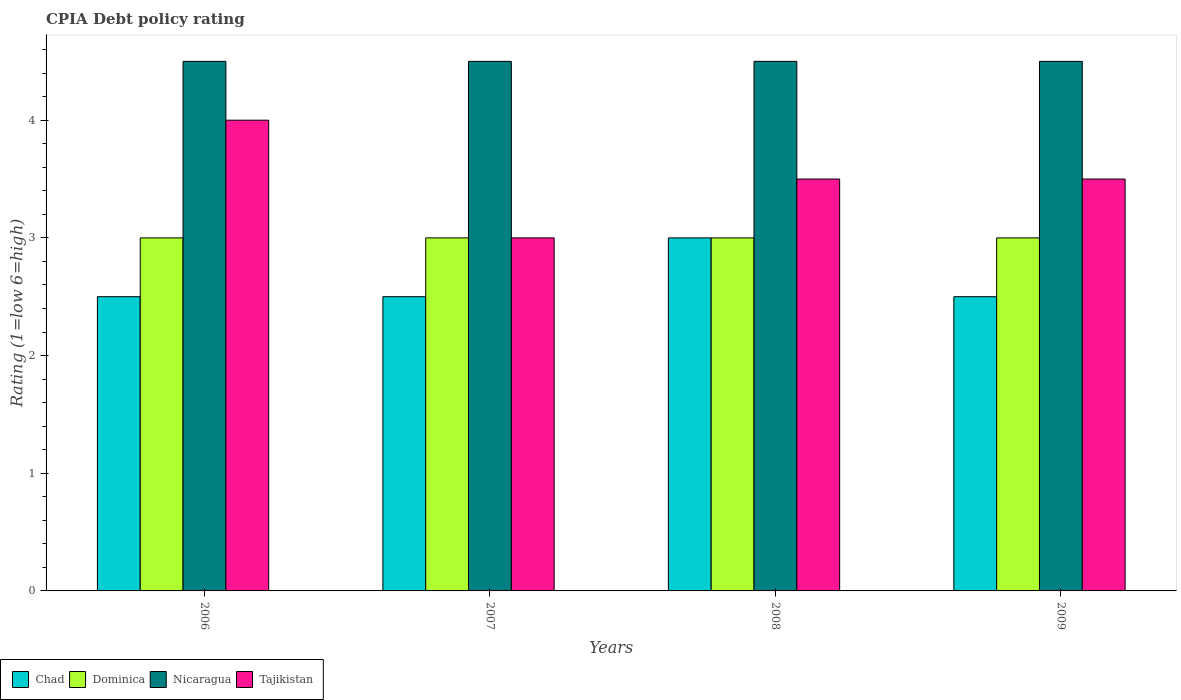How many different coloured bars are there?
Provide a short and direct response. 4. Are the number of bars on each tick of the X-axis equal?
Provide a short and direct response. Yes. How many bars are there on the 1st tick from the left?
Offer a very short reply. 4. How many bars are there on the 4th tick from the right?
Your answer should be compact. 4. What is the label of the 3rd group of bars from the left?
Your response must be concise. 2008. In how many cases, is the number of bars for a given year not equal to the number of legend labels?
Provide a succinct answer. 0. Across all years, what is the maximum CPIA rating in Nicaragua?
Your response must be concise. 4.5. Across all years, what is the minimum CPIA rating in Nicaragua?
Make the answer very short. 4.5. In which year was the CPIA rating in Chad minimum?
Your answer should be very brief. 2006. What is the difference between the CPIA rating in Chad in 2006 and that in 2009?
Offer a very short reply. 0. What is the difference between the CPIA rating in Dominica in 2008 and the CPIA rating in Nicaragua in 2006?
Your answer should be very brief. -1.5. What is the average CPIA rating in Dominica per year?
Offer a terse response. 3. In the year 2006, what is the difference between the CPIA rating in Chad and CPIA rating in Nicaragua?
Provide a succinct answer. -2. In how many years, is the CPIA rating in Chad greater than 1.4?
Ensure brevity in your answer.  4. What is the ratio of the CPIA rating in Tajikistan in 2006 to that in 2008?
Your response must be concise. 1.14. Is the CPIA rating in Tajikistan in 2006 less than that in 2009?
Give a very brief answer. No. What is the difference between the highest and the second highest CPIA rating in Dominica?
Ensure brevity in your answer.  0. What is the difference between the highest and the lowest CPIA rating in Chad?
Your answer should be compact. 0.5. In how many years, is the CPIA rating in Chad greater than the average CPIA rating in Chad taken over all years?
Offer a terse response. 1. Is the sum of the CPIA rating in Dominica in 2006 and 2009 greater than the maximum CPIA rating in Nicaragua across all years?
Make the answer very short. Yes. What does the 4th bar from the left in 2008 represents?
Make the answer very short. Tajikistan. What does the 2nd bar from the right in 2009 represents?
Your answer should be very brief. Nicaragua. Is it the case that in every year, the sum of the CPIA rating in Nicaragua and CPIA rating in Tajikistan is greater than the CPIA rating in Dominica?
Provide a short and direct response. Yes. How many bars are there?
Offer a terse response. 16. Are all the bars in the graph horizontal?
Give a very brief answer. No. What is the difference between two consecutive major ticks on the Y-axis?
Your response must be concise. 1. Are the values on the major ticks of Y-axis written in scientific E-notation?
Provide a succinct answer. No. What is the title of the graph?
Give a very brief answer. CPIA Debt policy rating. Does "Guatemala" appear as one of the legend labels in the graph?
Offer a terse response. No. What is the label or title of the X-axis?
Offer a very short reply. Years. What is the Rating (1=low 6=high) in Dominica in 2006?
Keep it short and to the point. 3. What is the Rating (1=low 6=high) in Nicaragua in 2006?
Provide a succinct answer. 4.5. What is the Rating (1=low 6=high) of Chad in 2007?
Ensure brevity in your answer.  2.5. What is the Rating (1=low 6=high) of Nicaragua in 2007?
Your answer should be very brief. 4.5. What is the Rating (1=low 6=high) in Chad in 2008?
Provide a short and direct response. 3. What is the Rating (1=low 6=high) of Dominica in 2008?
Offer a terse response. 3. What is the Rating (1=low 6=high) in Nicaragua in 2008?
Keep it short and to the point. 4.5. What is the Rating (1=low 6=high) in Tajikistan in 2008?
Make the answer very short. 3.5. What is the Rating (1=low 6=high) in Nicaragua in 2009?
Your response must be concise. 4.5. What is the Rating (1=low 6=high) of Tajikistan in 2009?
Offer a very short reply. 3.5. Across all years, what is the maximum Rating (1=low 6=high) in Dominica?
Keep it short and to the point. 3. Across all years, what is the minimum Rating (1=low 6=high) in Chad?
Make the answer very short. 2.5. Across all years, what is the minimum Rating (1=low 6=high) of Nicaragua?
Your answer should be compact. 4.5. What is the total Rating (1=low 6=high) in Chad in the graph?
Your answer should be compact. 10.5. What is the difference between the Rating (1=low 6=high) of Chad in 2006 and that in 2007?
Provide a short and direct response. 0. What is the difference between the Rating (1=low 6=high) of Dominica in 2006 and that in 2007?
Offer a terse response. 0. What is the difference between the Rating (1=low 6=high) of Nicaragua in 2006 and that in 2008?
Offer a very short reply. 0. What is the difference between the Rating (1=low 6=high) of Tajikistan in 2006 and that in 2008?
Offer a very short reply. 0.5. What is the difference between the Rating (1=low 6=high) of Chad in 2006 and that in 2009?
Offer a very short reply. 0. What is the difference between the Rating (1=low 6=high) in Dominica in 2006 and that in 2009?
Your answer should be very brief. 0. What is the difference between the Rating (1=low 6=high) in Nicaragua in 2006 and that in 2009?
Provide a short and direct response. 0. What is the difference between the Rating (1=low 6=high) of Tajikistan in 2006 and that in 2009?
Make the answer very short. 0.5. What is the difference between the Rating (1=low 6=high) of Chad in 2007 and that in 2008?
Make the answer very short. -0.5. What is the difference between the Rating (1=low 6=high) of Nicaragua in 2007 and that in 2008?
Ensure brevity in your answer.  0. What is the difference between the Rating (1=low 6=high) in Tajikistan in 2007 and that in 2008?
Your answer should be very brief. -0.5. What is the difference between the Rating (1=low 6=high) in Dominica in 2007 and that in 2009?
Offer a very short reply. 0. What is the difference between the Rating (1=low 6=high) in Nicaragua in 2008 and that in 2009?
Keep it short and to the point. 0. What is the difference between the Rating (1=low 6=high) in Tajikistan in 2008 and that in 2009?
Your answer should be compact. 0. What is the difference between the Rating (1=low 6=high) of Dominica in 2006 and the Rating (1=low 6=high) of Nicaragua in 2007?
Offer a terse response. -1.5. What is the difference between the Rating (1=low 6=high) in Dominica in 2006 and the Rating (1=low 6=high) in Nicaragua in 2008?
Give a very brief answer. -1.5. What is the difference between the Rating (1=low 6=high) in Dominica in 2006 and the Rating (1=low 6=high) in Tajikistan in 2008?
Make the answer very short. -0.5. What is the difference between the Rating (1=low 6=high) in Nicaragua in 2006 and the Rating (1=low 6=high) in Tajikistan in 2008?
Give a very brief answer. 1. What is the difference between the Rating (1=low 6=high) of Dominica in 2006 and the Rating (1=low 6=high) of Tajikistan in 2009?
Make the answer very short. -0.5. What is the difference between the Rating (1=low 6=high) of Nicaragua in 2006 and the Rating (1=low 6=high) of Tajikistan in 2009?
Provide a succinct answer. 1. What is the difference between the Rating (1=low 6=high) of Chad in 2007 and the Rating (1=low 6=high) of Dominica in 2008?
Offer a very short reply. -0.5. What is the difference between the Rating (1=low 6=high) in Chad in 2007 and the Rating (1=low 6=high) in Nicaragua in 2008?
Offer a very short reply. -2. What is the difference between the Rating (1=low 6=high) of Dominica in 2007 and the Rating (1=low 6=high) of Nicaragua in 2008?
Ensure brevity in your answer.  -1.5. What is the difference between the Rating (1=low 6=high) in Chad in 2007 and the Rating (1=low 6=high) in Nicaragua in 2009?
Ensure brevity in your answer.  -2. What is the difference between the Rating (1=low 6=high) of Chad in 2007 and the Rating (1=low 6=high) of Tajikistan in 2009?
Provide a succinct answer. -1. What is the difference between the Rating (1=low 6=high) in Dominica in 2007 and the Rating (1=low 6=high) in Nicaragua in 2009?
Provide a short and direct response. -1.5. What is the difference between the Rating (1=low 6=high) in Dominica in 2007 and the Rating (1=low 6=high) in Tajikistan in 2009?
Provide a short and direct response. -0.5. What is the difference between the Rating (1=low 6=high) in Chad in 2008 and the Rating (1=low 6=high) in Dominica in 2009?
Keep it short and to the point. 0. What is the difference between the Rating (1=low 6=high) of Chad in 2008 and the Rating (1=low 6=high) of Nicaragua in 2009?
Make the answer very short. -1.5. What is the difference between the Rating (1=low 6=high) in Dominica in 2008 and the Rating (1=low 6=high) in Nicaragua in 2009?
Ensure brevity in your answer.  -1.5. What is the difference between the Rating (1=low 6=high) of Dominica in 2008 and the Rating (1=low 6=high) of Tajikistan in 2009?
Keep it short and to the point. -0.5. What is the average Rating (1=low 6=high) in Chad per year?
Ensure brevity in your answer.  2.62. In the year 2006, what is the difference between the Rating (1=low 6=high) in Chad and Rating (1=low 6=high) in Dominica?
Your response must be concise. -0.5. In the year 2006, what is the difference between the Rating (1=low 6=high) of Chad and Rating (1=low 6=high) of Tajikistan?
Ensure brevity in your answer.  -1.5. In the year 2006, what is the difference between the Rating (1=low 6=high) of Dominica and Rating (1=low 6=high) of Nicaragua?
Offer a terse response. -1.5. In the year 2006, what is the difference between the Rating (1=low 6=high) of Dominica and Rating (1=low 6=high) of Tajikistan?
Give a very brief answer. -1. In the year 2007, what is the difference between the Rating (1=low 6=high) of Chad and Rating (1=low 6=high) of Nicaragua?
Offer a terse response. -2. In the year 2007, what is the difference between the Rating (1=low 6=high) of Chad and Rating (1=low 6=high) of Tajikistan?
Your response must be concise. -0.5. In the year 2007, what is the difference between the Rating (1=low 6=high) in Dominica and Rating (1=low 6=high) in Nicaragua?
Provide a short and direct response. -1.5. In the year 2007, what is the difference between the Rating (1=low 6=high) of Dominica and Rating (1=low 6=high) of Tajikistan?
Provide a succinct answer. 0. In the year 2008, what is the difference between the Rating (1=low 6=high) in Chad and Rating (1=low 6=high) in Dominica?
Your answer should be compact. 0. In the year 2008, what is the difference between the Rating (1=low 6=high) in Chad and Rating (1=low 6=high) in Nicaragua?
Offer a terse response. -1.5. In the year 2008, what is the difference between the Rating (1=low 6=high) in Chad and Rating (1=low 6=high) in Tajikistan?
Keep it short and to the point. -0.5. In the year 2008, what is the difference between the Rating (1=low 6=high) in Dominica and Rating (1=low 6=high) in Tajikistan?
Keep it short and to the point. -0.5. In the year 2009, what is the difference between the Rating (1=low 6=high) of Chad and Rating (1=low 6=high) of Dominica?
Keep it short and to the point. -0.5. In the year 2009, what is the difference between the Rating (1=low 6=high) in Chad and Rating (1=low 6=high) in Tajikistan?
Offer a terse response. -1. In the year 2009, what is the difference between the Rating (1=low 6=high) of Dominica and Rating (1=low 6=high) of Nicaragua?
Your answer should be compact. -1.5. In the year 2009, what is the difference between the Rating (1=low 6=high) in Dominica and Rating (1=low 6=high) in Tajikistan?
Make the answer very short. -0.5. In the year 2009, what is the difference between the Rating (1=low 6=high) of Nicaragua and Rating (1=low 6=high) of Tajikistan?
Provide a succinct answer. 1. What is the ratio of the Rating (1=low 6=high) in Chad in 2006 to that in 2007?
Keep it short and to the point. 1. What is the ratio of the Rating (1=low 6=high) of Dominica in 2006 to that in 2007?
Your answer should be very brief. 1. What is the ratio of the Rating (1=low 6=high) of Tajikistan in 2006 to that in 2007?
Provide a short and direct response. 1.33. What is the ratio of the Rating (1=low 6=high) of Chad in 2006 to that in 2008?
Ensure brevity in your answer.  0.83. What is the ratio of the Rating (1=low 6=high) of Dominica in 2006 to that in 2008?
Make the answer very short. 1. What is the ratio of the Rating (1=low 6=high) of Nicaragua in 2006 to that in 2008?
Offer a terse response. 1. What is the ratio of the Rating (1=low 6=high) of Chad in 2006 to that in 2009?
Provide a short and direct response. 1. What is the ratio of the Rating (1=low 6=high) of Dominica in 2006 to that in 2009?
Ensure brevity in your answer.  1. What is the ratio of the Rating (1=low 6=high) in Tajikistan in 2006 to that in 2009?
Your response must be concise. 1.14. What is the ratio of the Rating (1=low 6=high) of Chad in 2007 to that in 2008?
Make the answer very short. 0.83. What is the ratio of the Rating (1=low 6=high) in Dominica in 2007 to that in 2008?
Give a very brief answer. 1. What is the ratio of the Rating (1=low 6=high) in Tajikistan in 2007 to that in 2008?
Give a very brief answer. 0.86. What is the ratio of the Rating (1=low 6=high) in Dominica in 2007 to that in 2009?
Provide a short and direct response. 1. What is the ratio of the Rating (1=low 6=high) in Tajikistan in 2007 to that in 2009?
Your answer should be very brief. 0.86. What is the ratio of the Rating (1=low 6=high) of Chad in 2008 to that in 2009?
Your response must be concise. 1.2. What is the difference between the highest and the second highest Rating (1=low 6=high) of Nicaragua?
Offer a very short reply. 0. What is the difference between the highest and the lowest Rating (1=low 6=high) in Chad?
Provide a succinct answer. 0.5. 